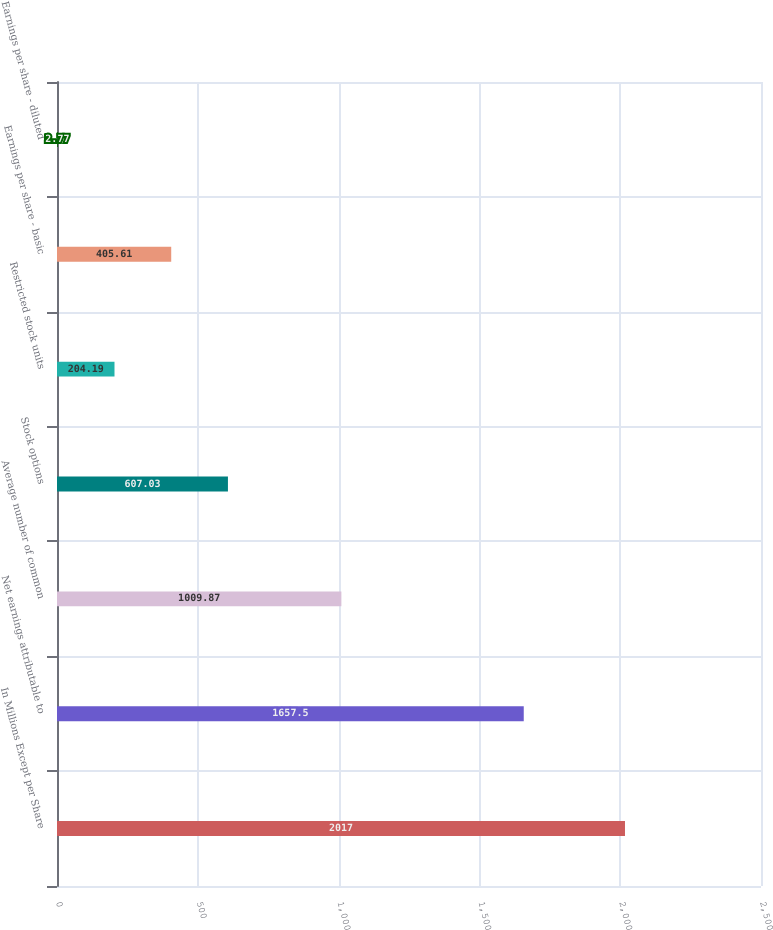<chart> <loc_0><loc_0><loc_500><loc_500><bar_chart><fcel>In Millions Except per Share<fcel>Net earnings attributable to<fcel>Average number of common<fcel>Stock options<fcel>Restricted stock units<fcel>Earnings per share - basic<fcel>Earnings per share - diluted<nl><fcel>2017<fcel>1657.5<fcel>1009.87<fcel>607.03<fcel>204.19<fcel>405.61<fcel>2.77<nl></chart> 